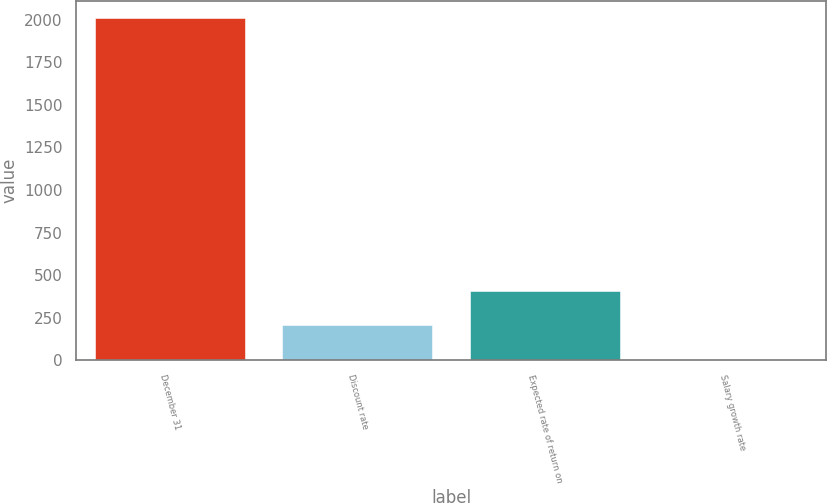Convert chart. <chart><loc_0><loc_0><loc_500><loc_500><bar_chart><fcel>December 31<fcel>Discount rate<fcel>Expected rate of return on<fcel>Salary growth rate<nl><fcel>2011<fcel>204.88<fcel>405.56<fcel>4.2<nl></chart> 